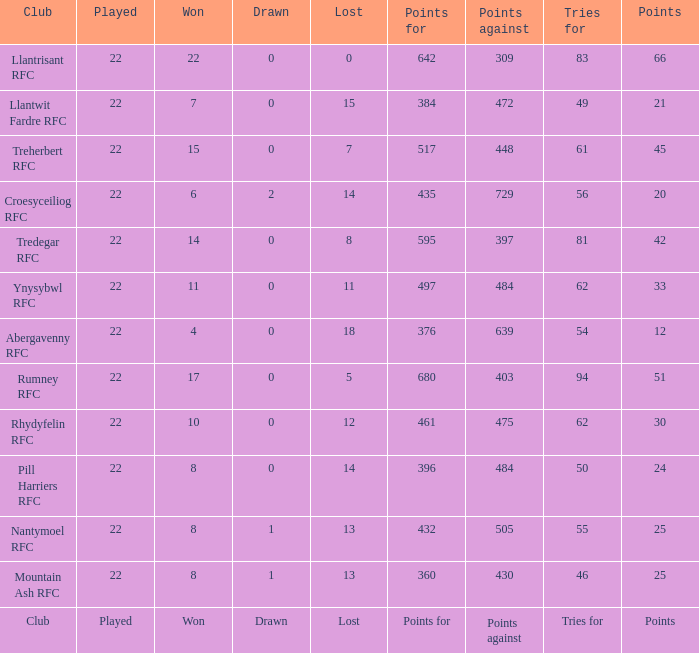How many points for were scored by the team that won exactly 22? 642.0. 